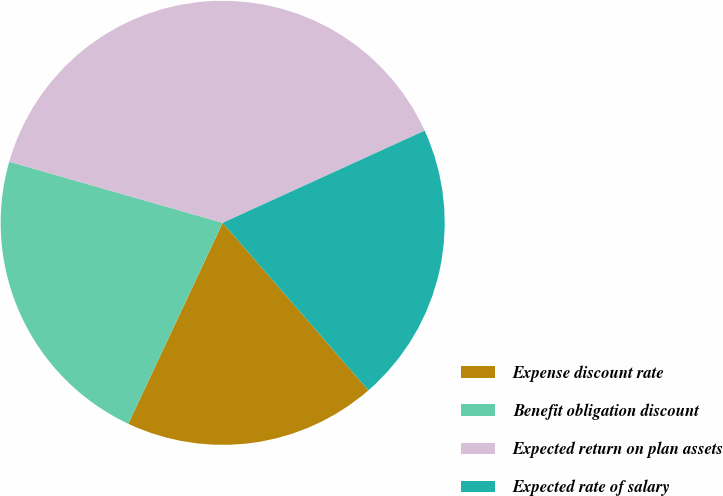Convert chart to OTSL. <chart><loc_0><loc_0><loc_500><loc_500><pie_chart><fcel>Expense discount rate<fcel>Benefit obligation discount<fcel>Expected return on plan assets<fcel>Expected rate of salary<nl><fcel>18.38%<fcel>22.45%<fcel>38.75%<fcel>20.42%<nl></chart> 